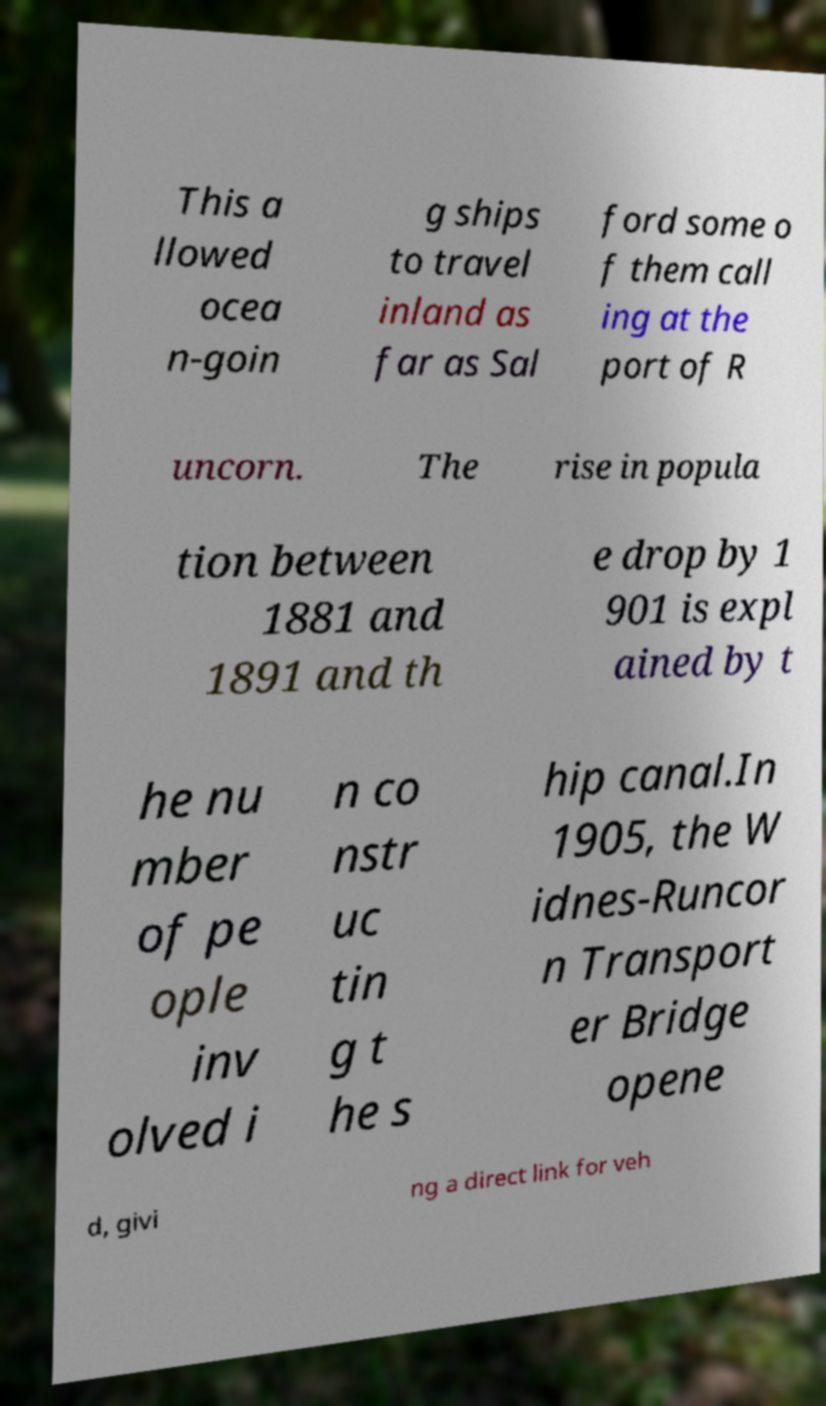Could you assist in decoding the text presented in this image and type it out clearly? This a llowed ocea n-goin g ships to travel inland as far as Sal ford some o f them call ing at the port of R uncorn. The rise in popula tion between 1881 and 1891 and th e drop by 1 901 is expl ained by t he nu mber of pe ople inv olved i n co nstr uc tin g t he s hip canal.In 1905, the W idnes-Runcor n Transport er Bridge opene d, givi ng a direct link for veh 